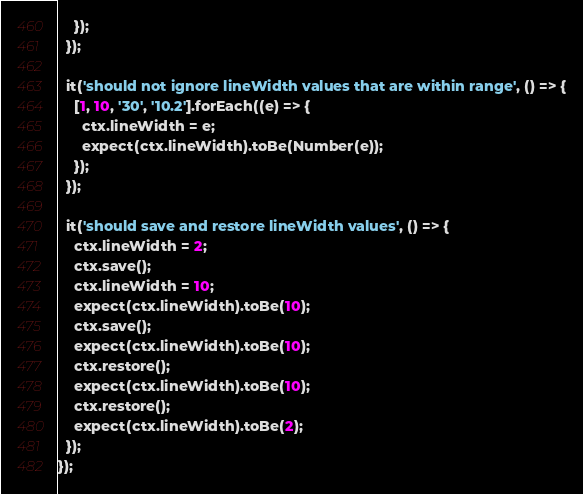<code> <loc_0><loc_0><loc_500><loc_500><_JavaScript_>    });
  });

  it('should not ignore lineWidth values that are within range', () => {
    [1, 10, '30', '10.2'].forEach((e) => {
      ctx.lineWidth = e;
      expect(ctx.lineWidth).toBe(Number(e));
    });
  });

  it('should save and restore lineWidth values', () => {
    ctx.lineWidth = 2;
    ctx.save();
    ctx.lineWidth = 10;
    expect(ctx.lineWidth).toBe(10);
    ctx.save();
    expect(ctx.lineWidth).toBe(10);
    ctx.restore();
    expect(ctx.lineWidth).toBe(10);
    ctx.restore();
    expect(ctx.lineWidth).toBe(2);
  });
});
</code> 